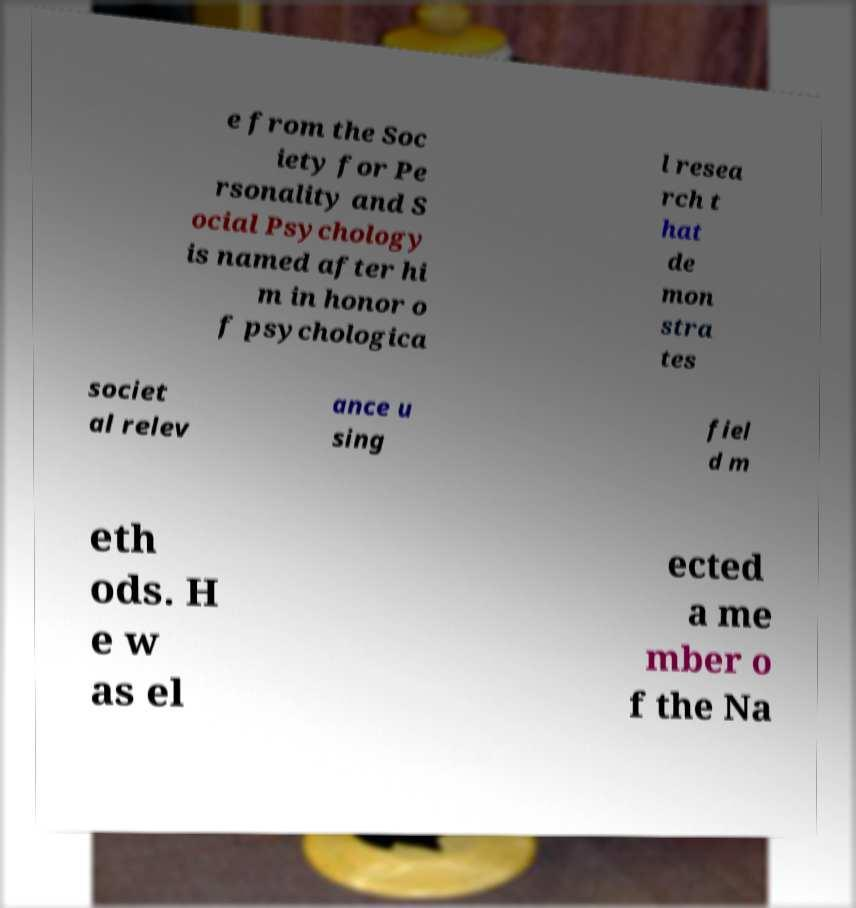For documentation purposes, I need the text within this image transcribed. Could you provide that? e from the Soc iety for Pe rsonality and S ocial Psychology is named after hi m in honor o f psychologica l resea rch t hat de mon stra tes societ al relev ance u sing fiel d m eth ods. H e w as el ected a me mber o f the Na 